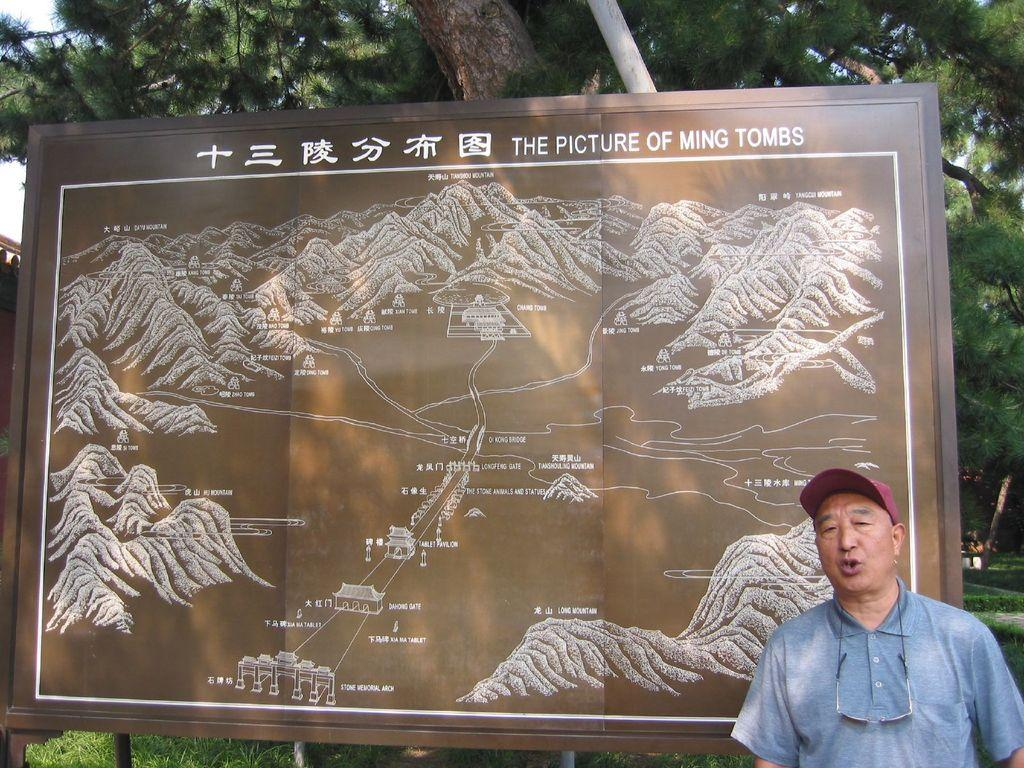Who is present in the image? There is a man in the image. Where is the man located in the image? The man is on the right side of the image. What is the board in the image used for? The board contains a map. What can be seen behind the board? There are trees behind the board. What type of boot is the man wearing in the image? There is no information about the man's footwear in the image, so it cannot be determined if he is wearing a boot or any other type of shoe. 